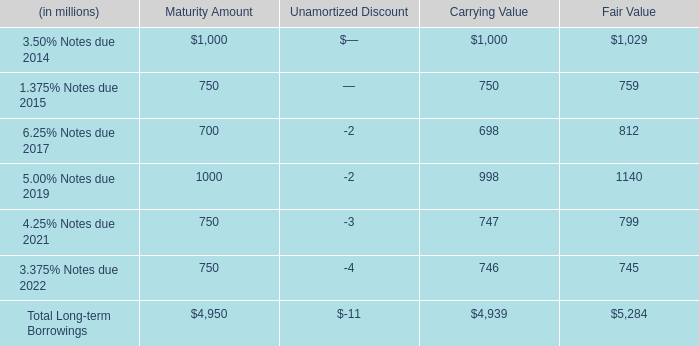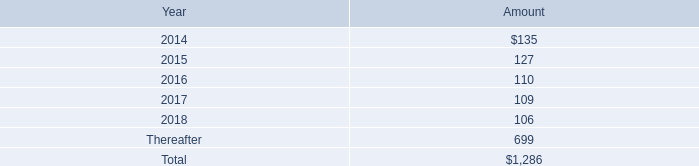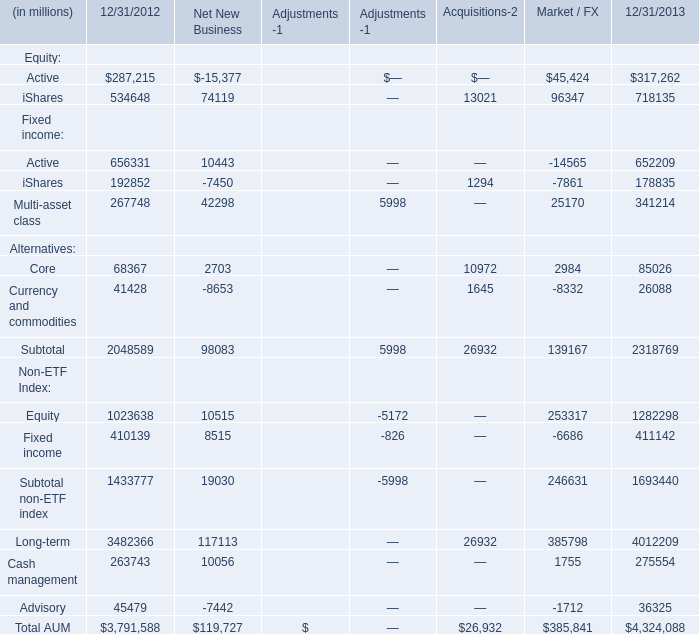what is the growth rate in rent expense and certain office equipment expense in 2012 compare to 2011? 
Computations: ((133 - 154) / 154)
Answer: -0.13636. 